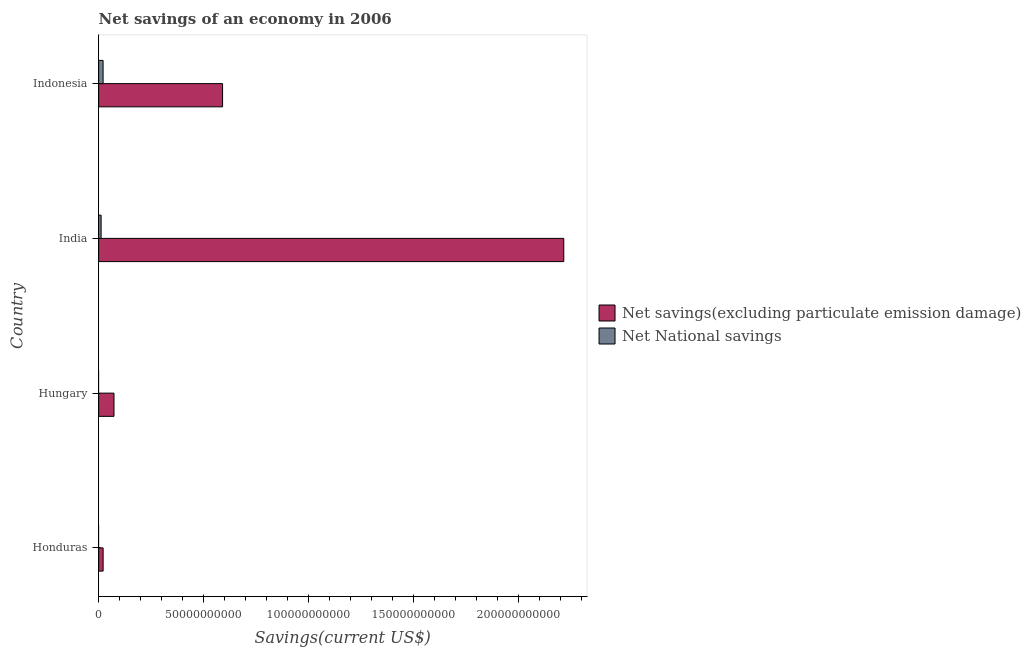Are the number of bars on each tick of the Y-axis equal?
Ensure brevity in your answer.  No. How many bars are there on the 3rd tick from the bottom?
Give a very brief answer. 2. What is the label of the 3rd group of bars from the top?
Offer a terse response. Hungary. In how many cases, is the number of bars for a given country not equal to the number of legend labels?
Your answer should be very brief. 2. What is the net savings(excluding particulate emission damage) in Honduras?
Your response must be concise. 2.14e+09. Across all countries, what is the maximum net savings(excluding particulate emission damage)?
Offer a terse response. 2.22e+11. Across all countries, what is the minimum net national savings?
Provide a short and direct response. 0. What is the total net national savings in the graph?
Provide a succinct answer. 3.31e+09. What is the difference between the net savings(excluding particulate emission damage) in Honduras and that in Indonesia?
Your answer should be compact. -5.70e+1. What is the difference between the net national savings in Hungary and the net savings(excluding particulate emission damage) in Indonesia?
Make the answer very short. -5.91e+1. What is the average net national savings per country?
Your answer should be very brief. 8.27e+08. What is the difference between the net national savings and net savings(excluding particulate emission damage) in Indonesia?
Offer a very short reply. -5.70e+1. In how many countries, is the net savings(excluding particulate emission damage) greater than 160000000000 US$?
Offer a terse response. 1. What is the ratio of the net savings(excluding particulate emission damage) in Hungary to that in India?
Ensure brevity in your answer.  0.03. Is the net savings(excluding particulate emission damage) in Honduras less than that in India?
Offer a terse response. Yes. What is the difference between the highest and the second highest net savings(excluding particulate emission damage)?
Give a very brief answer. 1.63e+11. What is the difference between the highest and the lowest net national savings?
Your response must be concise. 2.13e+09. In how many countries, is the net national savings greater than the average net national savings taken over all countries?
Offer a terse response. 2. How many bars are there?
Keep it short and to the point. 6. Are all the bars in the graph horizontal?
Ensure brevity in your answer.  Yes. What is the difference between two consecutive major ticks on the X-axis?
Your response must be concise. 5.00e+1. Does the graph contain any zero values?
Your response must be concise. Yes. How many legend labels are there?
Offer a very short reply. 2. How are the legend labels stacked?
Ensure brevity in your answer.  Vertical. What is the title of the graph?
Your answer should be very brief. Net savings of an economy in 2006. Does "Not attending school" appear as one of the legend labels in the graph?
Your answer should be compact. No. What is the label or title of the X-axis?
Offer a very short reply. Savings(current US$). What is the label or title of the Y-axis?
Give a very brief answer. Country. What is the Savings(current US$) of Net savings(excluding particulate emission damage) in Honduras?
Provide a succinct answer. 2.14e+09. What is the Savings(current US$) in Net National savings in Honduras?
Your response must be concise. 0. What is the Savings(current US$) of Net savings(excluding particulate emission damage) in Hungary?
Ensure brevity in your answer.  7.33e+09. What is the Savings(current US$) in Net savings(excluding particulate emission damage) in India?
Your answer should be compact. 2.22e+11. What is the Savings(current US$) in Net National savings in India?
Your answer should be compact. 1.18e+09. What is the Savings(current US$) of Net savings(excluding particulate emission damage) in Indonesia?
Ensure brevity in your answer.  5.91e+1. What is the Savings(current US$) in Net National savings in Indonesia?
Provide a succinct answer. 2.13e+09. Across all countries, what is the maximum Savings(current US$) in Net savings(excluding particulate emission damage)?
Offer a terse response. 2.22e+11. Across all countries, what is the maximum Savings(current US$) in Net National savings?
Offer a very short reply. 2.13e+09. Across all countries, what is the minimum Savings(current US$) of Net savings(excluding particulate emission damage)?
Provide a succinct answer. 2.14e+09. Across all countries, what is the minimum Savings(current US$) of Net National savings?
Your answer should be very brief. 0. What is the total Savings(current US$) in Net savings(excluding particulate emission damage) in the graph?
Your response must be concise. 2.90e+11. What is the total Savings(current US$) of Net National savings in the graph?
Your response must be concise. 3.31e+09. What is the difference between the Savings(current US$) in Net savings(excluding particulate emission damage) in Honduras and that in Hungary?
Ensure brevity in your answer.  -5.19e+09. What is the difference between the Savings(current US$) in Net savings(excluding particulate emission damage) in Honduras and that in India?
Your response must be concise. -2.20e+11. What is the difference between the Savings(current US$) of Net savings(excluding particulate emission damage) in Honduras and that in Indonesia?
Offer a terse response. -5.70e+1. What is the difference between the Savings(current US$) of Net savings(excluding particulate emission damage) in Hungary and that in India?
Your answer should be compact. -2.14e+11. What is the difference between the Savings(current US$) in Net savings(excluding particulate emission damage) in Hungary and that in Indonesia?
Provide a succinct answer. -5.18e+1. What is the difference between the Savings(current US$) of Net savings(excluding particulate emission damage) in India and that in Indonesia?
Keep it short and to the point. 1.63e+11. What is the difference between the Savings(current US$) of Net National savings in India and that in Indonesia?
Provide a succinct answer. -9.45e+08. What is the difference between the Savings(current US$) of Net savings(excluding particulate emission damage) in Honduras and the Savings(current US$) of Net National savings in India?
Keep it short and to the point. 9.60e+08. What is the difference between the Savings(current US$) of Net savings(excluding particulate emission damage) in Honduras and the Savings(current US$) of Net National savings in Indonesia?
Make the answer very short. 1.47e+07. What is the difference between the Savings(current US$) in Net savings(excluding particulate emission damage) in Hungary and the Savings(current US$) in Net National savings in India?
Provide a succinct answer. 6.15e+09. What is the difference between the Savings(current US$) in Net savings(excluding particulate emission damage) in Hungary and the Savings(current US$) in Net National savings in Indonesia?
Offer a very short reply. 5.20e+09. What is the difference between the Savings(current US$) in Net savings(excluding particulate emission damage) in India and the Savings(current US$) in Net National savings in Indonesia?
Offer a very short reply. 2.20e+11. What is the average Savings(current US$) of Net savings(excluding particulate emission damage) per country?
Make the answer very short. 7.26e+1. What is the average Savings(current US$) in Net National savings per country?
Keep it short and to the point. 8.27e+08. What is the difference between the Savings(current US$) in Net savings(excluding particulate emission damage) and Savings(current US$) in Net National savings in India?
Your answer should be compact. 2.21e+11. What is the difference between the Savings(current US$) of Net savings(excluding particulate emission damage) and Savings(current US$) of Net National savings in Indonesia?
Offer a very short reply. 5.70e+1. What is the ratio of the Savings(current US$) in Net savings(excluding particulate emission damage) in Honduras to that in Hungary?
Keep it short and to the point. 0.29. What is the ratio of the Savings(current US$) in Net savings(excluding particulate emission damage) in Honduras to that in India?
Ensure brevity in your answer.  0.01. What is the ratio of the Savings(current US$) in Net savings(excluding particulate emission damage) in Honduras to that in Indonesia?
Ensure brevity in your answer.  0.04. What is the ratio of the Savings(current US$) of Net savings(excluding particulate emission damage) in Hungary to that in India?
Offer a very short reply. 0.03. What is the ratio of the Savings(current US$) of Net savings(excluding particulate emission damage) in Hungary to that in Indonesia?
Your response must be concise. 0.12. What is the ratio of the Savings(current US$) in Net savings(excluding particulate emission damage) in India to that in Indonesia?
Your answer should be compact. 3.75. What is the ratio of the Savings(current US$) in Net National savings in India to that in Indonesia?
Offer a terse response. 0.56. What is the difference between the highest and the second highest Savings(current US$) in Net savings(excluding particulate emission damage)?
Give a very brief answer. 1.63e+11. What is the difference between the highest and the lowest Savings(current US$) of Net savings(excluding particulate emission damage)?
Provide a succinct answer. 2.20e+11. What is the difference between the highest and the lowest Savings(current US$) in Net National savings?
Your answer should be very brief. 2.13e+09. 